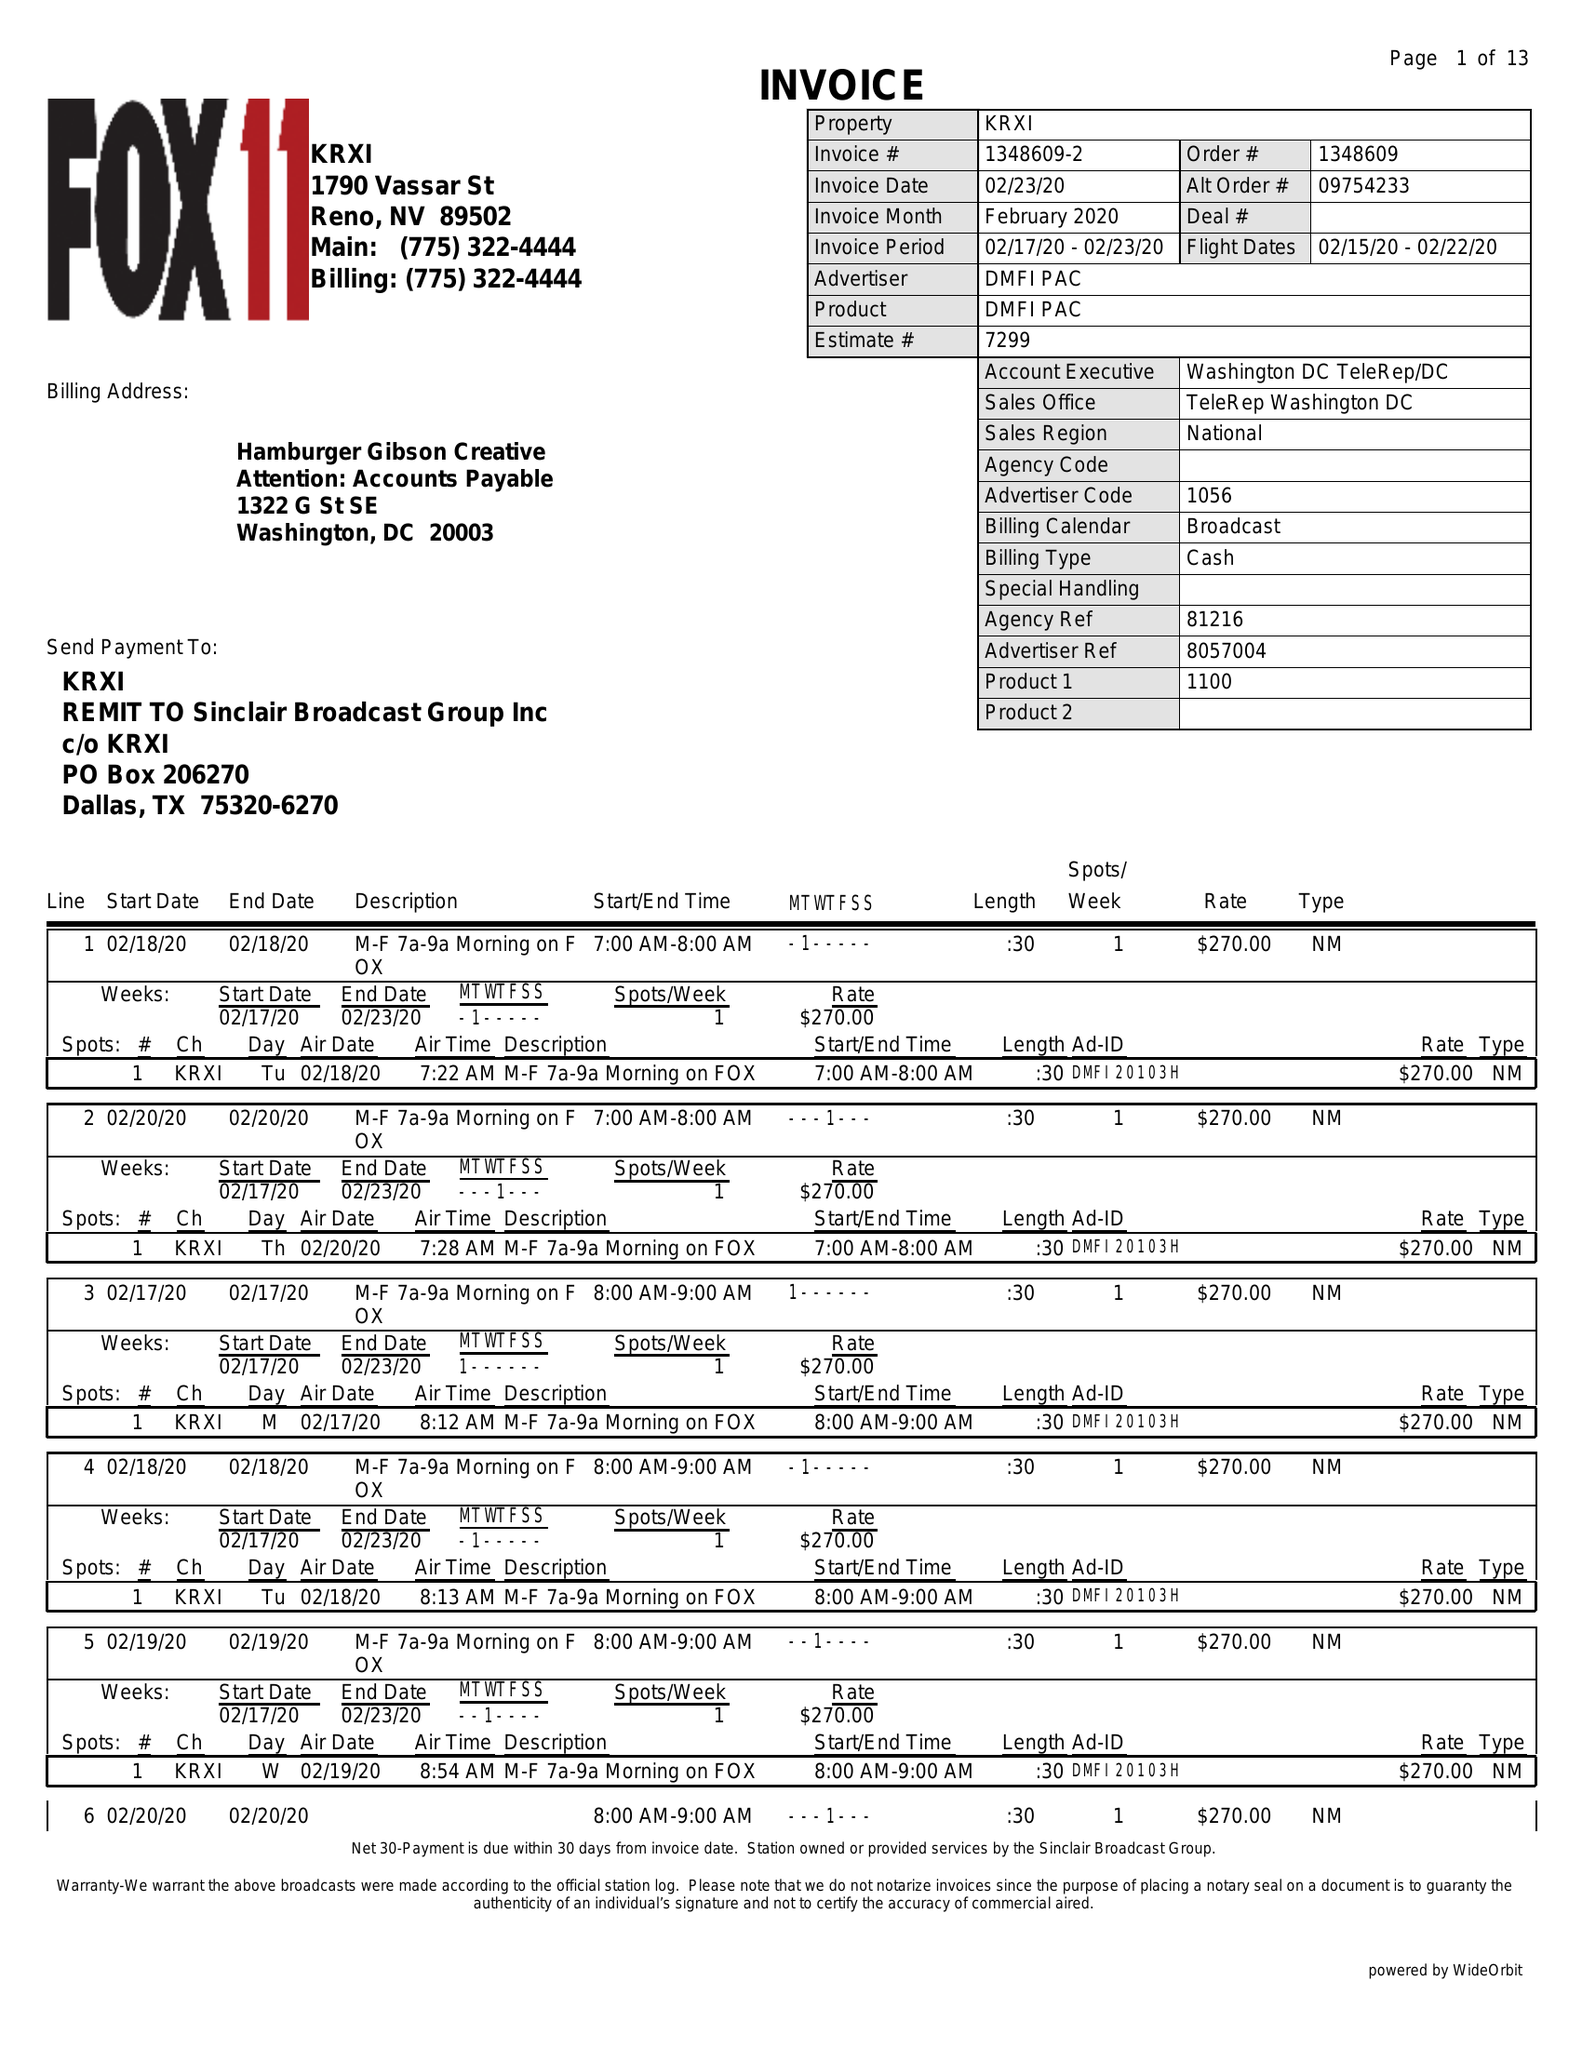What is the value for the advertiser?
Answer the question using a single word or phrase. DMFI PAC 